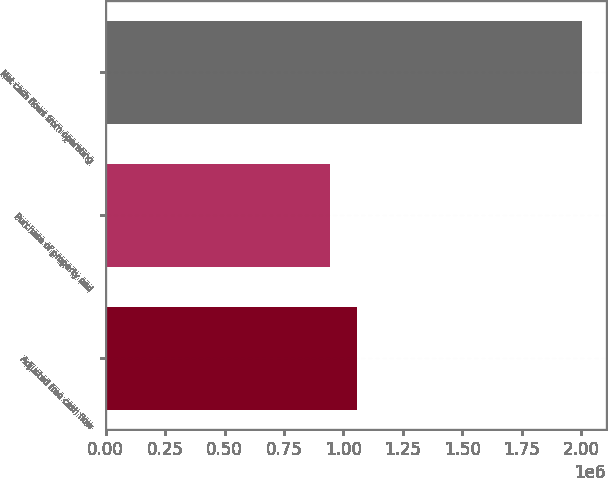<chart> <loc_0><loc_0><loc_500><loc_500><bar_chart><fcel>Adjusted free cash flow<fcel>Purchase of property and<fcel>Net cash flows from operating<nl><fcel>1.05838e+06<fcel>945334<fcel>2.00372e+06<nl></chart> 